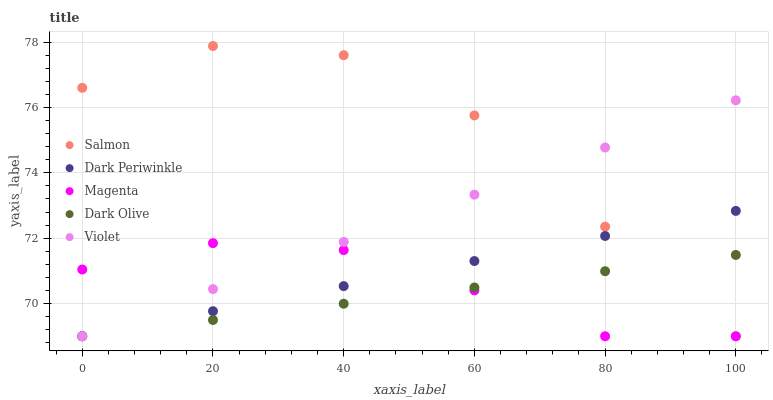Does Dark Olive have the minimum area under the curve?
Answer yes or no. Yes. Does Salmon have the maximum area under the curve?
Answer yes or no. Yes. Does Salmon have the minimum area under the curve?
Answer yes or no. No. Does Dark Olive have the maximum area under the curve?
Answer yes or no. No. Is Dark Periwinkle the smoothest?
Answer yes or no. Yes. Is Salmon the roughest?
Answer yes or no. Yes. Is Dark Olive the smoothest?
Answer yes or no. No. Is Dark Olive the roughest?
Answer yes or no. No. Does Magenta have the lowest value?
Answer yes or no. Yes. Does Salmon have the highest value?
Answer yes or no. Yes. Does Dark Olive have the highest value?
Answer yes or no. No. Does Dark Periwinkle intersect Dark Olive?
Answer yes or no. Yes. Is Dark Periwinkle less than Dark Olive?
Answer yes or no. No. Is Dark Periwinkle greater than Dark Olive?
Answer yes or no. No. 